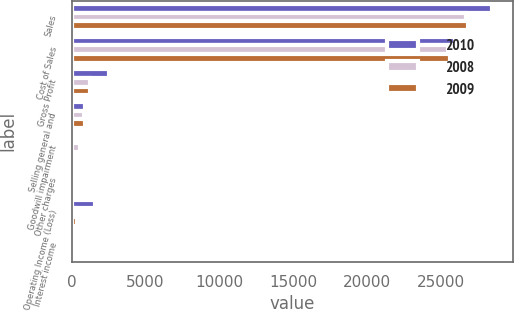<chart> <loc_0><loc_0><loc_500><loc_500><stacked_bar_chart><ecel><fcel>Sales<fcel>Cost of Sales<fcel>Gross Profit<fcel>Selling general and<fcel>Goodwill impairment<fcel>Other charges<fcel>Operating Income (Loss)<fcel>Interest income<nl><fcel>2010<fcel>28430<fcel>25916<fcel>2514<fcel>929<fcel>29<fcel>0<fcel>1556<fcel>14<nl><fcel>2008<fcel>26704<fcel>25501<fcel>1203<fcel>841<fcel>560<fcel>17<fcel>215<fcel>17<nl><fcel>2009<fcel>26862<fcel>25616<fcel>1246<fcel>879<fcel>0<fcel>36<fcel>331<fcel>9<nl></chart> 